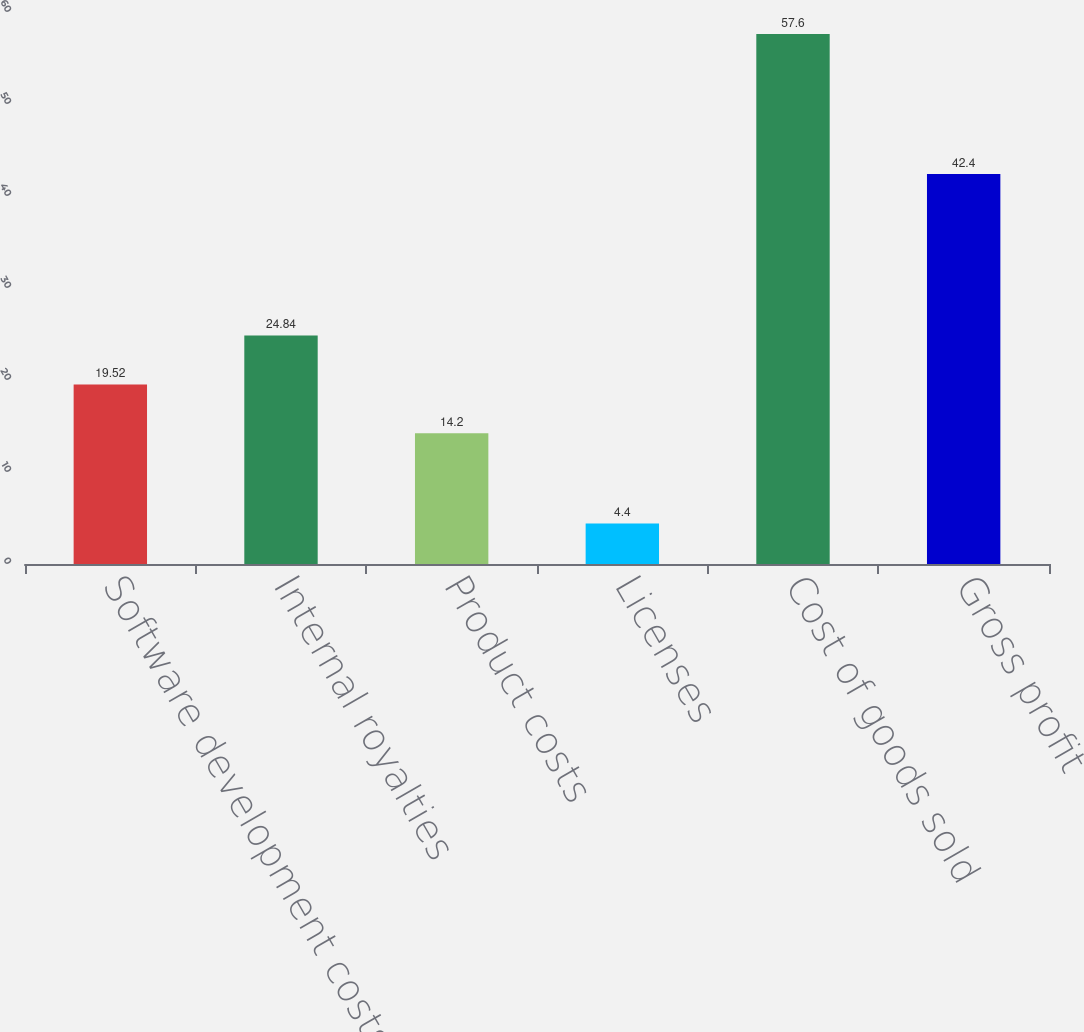Convert chart to OTSL. <chart><loc_0><loc_0><loc_500><loc_500><bar_chart><fcel>Software development costs and<fcel>Internal royalties<fcel>Product costs<fcel>Licenses<fcel>Cost of goods sold<fcel>Gross profit<nl><fcel>19.52<fcel>24.84<fcel>14.2<fcel>4.4<fcel>57.6<fcel>42.4<nl></chart> 